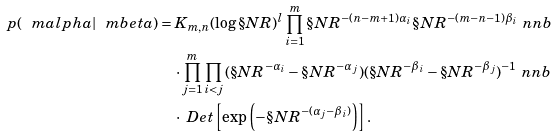Convert formula to latex. <formula><loc_0><loc_0><loc_500><loc_500>p ( \ m a l p h a | \ m b e t a ) & = K _ { m , n } ( \log \S N R ) ^ { l } \prod _ { i = 1 } ^ { m } \S N R ^ { - ( n - m + 1 ) \alpha _ { i } } \S N R ^ { - ( m - n - 1 ) \beta _ { i } } \ n n b \\ & \quad \cdot \prod _ { j = 1 } ^ { m } \prod _ { i < j } { ( \S N R ^ { - \alpha _ { i } } - \S N R ^ { - \alpha _ { j } } ) } { ( \S N R ^ { - \beta _ { i } } - \S N R ^ { - \beta _ { j } } ) ^ { - 1 } } \ n n b \\ & \quad \cdot \ D e t \left [ \exp \left ( - \S N R ^ { - ( \alpha _ { j } - \beta _ { i } ) } \right ) \right ] .</formula> 